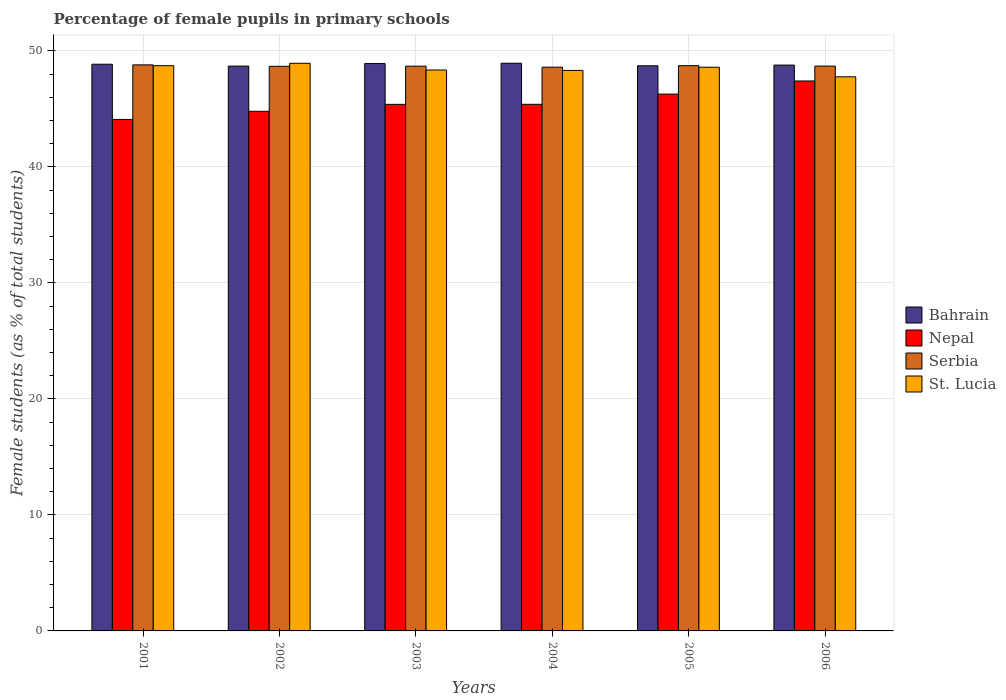How many different coloured bars are there?
Keep it short and to the point. 4. Are the number of bars per tick equal to the number of legend labels?
Offer a terse response. Yes. How many bars are there on the 2nd tick from the right?
Keep it short and to the point. 4. What is the percentage of female pupils in primary schools in St. Lucia in 2006?
Your answer should be compact. 47.77. Across all years, what is the maximum percentage of female pupils in primary schools in St. Lucia?
Provide a short and direct response. 48.93. Across all years, what is the minimum percentage of female pupils in primary schools in Nepal?
Make the answer very short. 44.09. What is the total percentage of female pupils in primary schools in Bahrain in the graph?
Provide a succinct answer. 292.89. What is the difference between the percentage of female pupils in primary schools in Serbia in 2005 and that in 2006?
Ensure brevity in your answer.  0.04. What is the difference between the percentage of female pupils in primary schools in Nepal in 2003 and the percentage of female pupils in primary schools in Bahrain in 2001?
Give a very brief answer. -3.46. What is the average percentage of female pupils in primary schools in Serbia per year?
Give a very brief answer. 48.7. In the year 2006, what is the difference between the percentage of female pupils in primary schools in Nepal and percentage of female pupils in primary schools in St. Lucia?
Provide a short and direct response. -0.36. In how many years, is the percentage of female pupils in primary schools in Nepal greater than 6 %?
Ensure brevity in your answer.  6. What is the ratio of the percentage of female pupils in primary schools in St. Lucia in 2001 to that in 2006?
Your answer should be very brief. 1.02. Is the percentage of female pupils in primary schools in Serbia in 2002 less than that in 2004?
Keep it short and to the point. No. Is the difference between the percentage of female pupils in primary schools in Nepal in 2005 and 2006 greater than the difference between the percentage of female pupils in primary schools in St. Lucia in 2005 and 2006?
Provide a succinct answer. No. What is the difference between the highest and the second highest percentage of female pupils in primary schools in Bahrain?
Provide a succinct answer. 0.03. What is the difference between the highest and the lowest percentage of female pupils in primary schools in St. Lucia?
Ensure brevity in your answer.  1.17. In how many years, is the percentage of female pupils in primary schools in Nepal greater than the average percentage of female pupils in primary schools in Nepal taken over all years?
Offer a very short reply. 2. What does the 4th bar from the left in 2001 represents?
Make the answer very short. St. Lucia. What does the 1st bar from the right in 2004 represents?
Give a very brief answer. St. Lucia. Is it the case that in every year, the sum of the percentage of female pupils in primary schools in Serbia and percentage of female pupils in primary schools in St. Lucia is greater than the percentage of female pupils in primary schools in Nepal?
Your response must be concise. Yes. How many bars are there?
Make the answer very short. 24. How many years are there in the graph?
Provide a short and direct response. 6. What is the difference between two consecutive major ticks on the Y-axis?
Offer a terse response. 10. Are the values on the major ticks of Y-axis written in scientific E-notation?
Make the answer very short. No. Does the graph contain any zero values?
Ensure brevity in your answer.  No. Does the graph contain grids?
Provide a short and direct response. Yes. Where does the legend appear in the graph?
Your answer should be compact. Center right. How are the legend labels stacked?
Keep it short and to the point. Vertical. What is the title of the graph?
Provide a succinct answer. Percentage of female pupils in primary schools. What is the label or title of the X-axis?
Provide a succinct answer. Years. What is the label or title of the Y-axis?
Offer a very short reply. Female students (as % of total students). What is the Female students (as % of total students) in Bahrain in 2001?
Provide a short and direct response. 48.85. What is the Female students (as % of total students) of Nepal in 2001?
Give a very brief answer. 44.09. What is the Female students (as % of total students) of Serbia in 2001?
Offer a very short reply. 48.8. What is the Female students (as % of total students) of St. Lucia in 2001?
Your answer should be compact. 48.73. What is the Female students (as % of total students) of Bahrain in 2002?
Offer a very short reply. 48.69. What is the Female students (as % of total students) of Nepal in 2002?
Make the answer very short. 44.8. What is the Female students (as % of total students) in Serbia in 2002?
Your answer should be very brief. 48.67. What is the Female students (as % of total students) of St. Lucia in 2002?
Offer a very short reply. 48.93. What is the Female students (as % of total students) of Bahrain in 2003?
Keep it short and to the point. 48.91. What is the Female students (as % of total students) of Nepal in 2003?
Provide a short and direct response. 45.39. What is the Female students (as % of total students) of Serbia in 2003?
Your response must be concise. 48.69. What is the Female students (as % of total students) of St. Lucia in 2003?
Your response must be concise. 48.35. What is the Female students (as % of total students) of Bahrain in 2004?
Provide a short and direct response. 48.94. What is the Female students (as % of total students) of Nepal in 2004?
Ensure brevity in your answer.  45.4. What is the Female students (as % of total students) in Serbia in 2004?
Provide a succinct answer. 48.6. What is the Female students (as % of total students) of St. Lucia in 2004?
Offer a terse response. 48.32. What is the Female students (as % of total students) in Bahrain in 2005?
Your answer should be very brief. 48.72. What is the Female students (as % of total students) in Nepal in 2005?
Give a very brief answer. 46.28. What is the Female students (as % of total students) of Serbia in 2005?
Ensure brevity in your answer.  48.73. What is the Female students (as % of total students) in St. Lucia in 2005?
Provide a short and direct response. 48.59. What is the Female students (as % of total students) in Bahrain in 2006?
Provide a short and direct response. 48.78. What is the Female students (as % of total students) of Nepal in 2006?
Provide a short and direct response. 47.41. What is the Female students (as % of total students) in Serbia in 2006?
Offer a very short reply. 48.69. What is the Female students (as % of total students) of St. Lucia in 2006?
Make the answer very short. 47.77. Across all years, what is the maximum Female students (as % of total students) in Bahrain?
Your answer should be very brief. 48.94. Across all years, what is the maximum Female students (as % of total students) in Nepal?
Keep it short and to the point. 47.41. Across all years, what is the maximum Female students (as % of total students) in Serbia?
Offer a terse response. 48.8. Across all years, what is the maximum Female students (as % of total students) in St. Lucia?
Ensure brevity in your answer.  48.93. Across all years, what is the minimum Female students (as % of total students) in Bahrain?
Offer a terse response. 48.69. Across all years, what is the minimum Female students (as % of total students) in Nepal?
Keep it short and to the point. 44.09. Across all years, what is the minimum Female students (as % of total students) of Serbia?
Offer a very short reply. 48.6. Across all years, what is the minimum Female students (as % of total students) of St. Lucia?
Offer a terse response. 47.77. What is the total Female students (as % of total students) of Bahrain in the graph?
Make the answer very short. 292.88. What is the total Female students (as % of total students) in Nepal in the graph?
Provide a succinct answer. 273.37. What is the total Female students (as % of total students) of Serbia in the graph?
Ensure brevity in your answer.  292.17. What is the total Female students (as % of total students) of St. Lucia in the graph?
Provide a short and direct response. 290.69. What is the difference between the Female students (as % of total students) in Bahrain in 2001 and that in 2002?
Provide a short and direct response. 0.16. What is the difference between the Female students (as % of total students) of Nepal in 2001 and that in 2002?
Ensure brevity in your answer.  -0.7. What is the difference between the Female students (as % of total students) in Serbia in 2001 and that in 2002?
Offer a very short reply. 0.12. What is the difference between the Female students (as % of total students) in St. Lucia in 2001 and that in 2002?
Ensure brevity in your answer.  -0.21. What is the difference between the Female students (as % of total students) in Bahrain in 2001 and that in 2003?
Ensure brevity in your answer.  -0.06. What is the difference between the Female students (as % of total students) in Nepal in 2001 and that in 2003?
Provide a succinct answer. -1.3. What is the difference between the Female students (as % of total students) in Serbia in 2001 and that in 2003?
Provide a short and direct response. 0.11. What is the difference between the Female students (as % of total students) in St. Lucia in 2001 and that in 2003?
Ensure brevity in your answer.  0.37. What is the difference between the Female students (as % of total students) of Bahrain in 2001 and that in 2004?
Your response must be concise. -0.08. What is the difference between the Female students (as % of total students) of Nepal in 2001 and that in 2004?
Keep it short and to the point. -1.3. What is the difference between the Female students (as % of total students) in Serbia in 2001 and that in 2004?
Provide a succinct answer. 0.2. What is the difference between the Female students (as % of total students) in St. Lucia in 2001 and that in 2004?
Ensure brevity in your answer.  0.41. What is the difference between the Female students (as % of total students) in Bahrain in 2001 and that in 2005?
Provide a short and direct response. 0.13. What is the difference between the Female students (as % of total students) of Nepal in 2001 and that in 2005?
Offer a terse response. -2.18. What is the difference between the Female students (as % of total students) of Serbia in 2001 and that in 2005?
Offer a terse response. 0.07. What is the difference between the Female students (as % of total students) of St. Lucia in 2001 and that in 2005?
Offer a terse response. 0.13. What is the difference between the Female students (as % of total students) of Bahrain in 2001 and that in 2006?
Provide a short and direct response. 0.07. What is the difference between the Female students (as % of total students) in Nepal in 2001 and that in 2006?
Your answer should be very brief. -3.31. What is the difference between the Female students (as % of total students) in Serbia in 2001 and that in 2006?
Ensure brevity in your answer.  0.1. What is the difference between the Female students (as % of total students) of St. Lucia in 2001 and that in 2006?
Give a very brief answer. 0.96. What is the difference between the Female students (as % of total students) in Bahrain in 2002 and that in 2003?
Ensure brevity in your answer.  -0.22. What is the difference between the Female students (as % of total students) of Nepal in 2002 and that in 2003?
Give a very brief answer. -0.6. What is the difference between the Female students (as % of total students) of Serbia in 2002 and that in 2003?
Your answer should be compact. -0.01. What is the difference between the Female students (as % of total students) in St. Lucia in 2002 and that in 2003?
Keep it short and to the point. 0.58. What is the difference between the Female students (as % of total students) in Bahrain in 2002 and that in 2004?
Give a very brief answer. -0.24. What is the difference between the Female students (as % of total students) in Nepal in 2002 and that in 2004?
Provide a succinct answer. -0.6. What is the difference between the Female students (as % of total students) of Serbia in 2002 and that in 2004?
Give a very brief answer. 0.07. What is the difference between the Female students (as % of total students) in St. Lucia in 2002 and that in 2004?
Your answer should be very brief. 0.62. What is the difference between the Female students (as % of total students) of Bahrain in 2002 and that in 2005?
Your answer should be very brief. -0.03. What is the difference between the Female students (as % of total students) in Nepal in 2002 and that in 2005?
Give a very brief answer. -1.48. What is the difference between the Female students (as % of total students) in Serbia in 2002 and that in 2005?
Your answer should be very brief. -0.06. What is the difference between the Female students (as % of total students) of St. Lucia in 2002 and that in 2005?
Offer a terse response. 0.34. What is the difference between the Female students (as % of total students) in Bahrain in 2002 and that in 2006?
Offer a terse response. -0.09. What is the difference between the Female students (as % of total students) in Nepal in 2002 and that in 2006?
Your answer should be very brief. -2.61. What is the difference between the Female students (as % of total students) in Serbia in 2002 and that in 2006?
Give a very brief answer. -0.02. What is the difference between the Female students (as % of total students) in St. Lucia in 2002 and that in 2006?
Give a very brief answer. 1.17. What is the difference between the Female students (as % of total students) of Bahrain in 2003 and that in 2004?
Your answer should be very brief. -0.03. What is the difference between the Female students (as % of total students) in Nepal in 2003 and that in 2004?
Make the answer very short. -0. What is the difference between the Female students (as % of total students) in Serbia in 2003 and that in 2004?
Make the answer very short. 0.09. What is the difference between the Female students (as % of total students) in St. Lucia in 2003 and that in 2004?
Give a very brief answer. 0.04. What is the difference between the Female students (as % of total students) of Bahrain in 2003 and that in 2005?
Provide a short and direct response. 0.19. What is the difference between the Female students (as % of total students) in Nepal in 2003 and that in 2005?
Make the answer very short. -0.88. What is the difference between the Female students (as % of total students) of Serbia in 2003 and that in 2005?
Your answer should be compact. -0.04. What is the difference between the Female students (as % of total students) in St. Lucia in 2003 and that in 2005?
Keep it short and to the point. -0.24. What is the difference between the Female students (as % of total students) of Bahrain in 2003 and that in 2006?
Your answer should be very brief. 0.13. What is the difference between the Female students (as % of total students) in Nepal in 2003 and that in 2006?
Make the answer very short. -2.01. What is the difference between the Female students (as % of total students) in Serbia in 2003 and that in 2006?
Provide a succinct answer. -0.01. What is the difference between the Female students (as % of total students) of St. Lucia in 2003 and that in 2006?
Offer a terse response. 0.59. What is the difference between the Female students (as % of total students) in Bahrain in 2004 and that in 2005?
Give a very brief answer. 0.22. What is the difference between the Female students (as % of total students) in Nepal in 2004 and that in 2005?
Your answer should be compact. -0.88. What is the difference between the Female students (as % of total students) in Serbia in 2004 and that in 2005?
Offer a very short reply. -0.13. What is the difference between the Female students (as % of total students) in St. Lucia in 2004 and that in 2005?
Provide a short and direct response. -0.28. What is the difference between the Female students (as % of total students) in Bahrain in 2004 and that in 2006?
Your answer should be very brief. 0.16. What is the difference between the Female students (as % of total students) in Nepal in 2004 and that in 2006?
Give a very brief answer. -2.01. What is the difference between the Female students (as % of total students) of Serbia in 2004 and that in 2006?
Provide a short and direct response. -0.09. What is the difference between the Female students (as % of total students) of St. Lucia in 2004 and that in 2006?
Provide a succinct answer. 0.55. What is the difference between the Female students (as % of total students) of Bahrain in 2005 and that in 2006?
Your answer should be very brief. -0.06. What is the difference between the Female students (as % of total students) of Nepal in 2005 and that in 2006?
Your answer should be very brief. -1.13. What is the difference between the Female students (as % of total students) in Serbia in 2005 and that in 2006?
Ensure brevity in your answer.  0.04. What is the difference between the Female students (as % of total students) in St. Lucia in 2005 and that in 2006?
Your answer should be very brief. 0.83. What is the difference between the Female students (as % of total students) in Bahrain in 2001 and the Female students (as % of total students) in Nepal in 2002?
Provide a short and direct response. 4.06. What is the difference between the Female students (as % of total students) of Bahrain in 2001 and the Female students (as % of total students) of Serbia in 2002?
Offer a very short reply. 0.18. What is the difference between the Female students (as % of total students) of Bahrain in 2001 and the Female students (as % of total students) of St. Lucia in 2002?
Your answer should be very brief. -0.08. What is the difference between the Female students (as % of total students) in Nepal in 2001 and the Female students (as % of total students) in Serbia in 2002?
Keep it short and to the point. -4.58. What is the difference between the Female students (as % of total students) in Nepal in 2001 and the Female students (as % of total students) in St. Lucia in 2002?
Offer a terse response. -4.84. What is the difference between the Female students (as % of total students) in Serbia in 2001 and the Female students (as % of total students) in St. Lucia in 2002?
Your answer should be very brief. -0.14. What is the difference between the Female students (as % of total students) of Bahrain in 2001 and the Female students (as % of total students) of Nepal in 2003?
Offer a very short reply. 3.46. What is the difference between the Female students (as % of total students) of Bahrain in 2001 and the Female students (as % of total students) of Serbia in 2003?
Offer a terse response. 0.17. What is the difference between the Female students (as % of total students) in Bahrain in 2001 and the Female students (as % of total students) in St. Lucia in 2003?
Your response must be concise. 0.5. What is the difference between the Female students (as % of total students) of Nepal in 2001 and the Female students (as % of total students) of Serbia in 2003?
Your answer should be compact. -4.59. What is the difference between the Female students (as % of total students) of Nepal in 2001 and the Female students (as % of total students) of St. Lucia in 2003?
Offer a very short reply. -4.26. What is the difference between the Female students (as % of total students) of Serbia in 2001 and the Female students (as % of total students) of St. Lucia in 2003?
Your answer should be very brief. 0.44. What is the difference between the Female students (as % of total students) in Bahrain in 2001 and the Female students (as % of total students) in Nepal in 2004?
Give a very brief answer. 3.45. What is the difference between the Female students (as % of total students) of Bahrain in 2001 and the Female students (as % of total students) of Serbia in 2004?
Make the answer very short. 0.25. What is the difference between the Female students (as % of total students) in Bahrain in 2001 and the Female students (as % of total students) in St. Lucia in 2004?
Ensure brevity in your answer.  0.53. What is the difference between the Female students (as % of total students) in Nepal in 2001 and the Female students (as % of total students) in Serbia in 2004?
Provide a succinct answer. -4.5. What is the difference between the Female students (as % of total students) of Nepal in 2001 and the Female students (as % of total students) of St. Lucia in 2004?
Your answer should be very brief. -4.23. What is the difference between the Female students (as % of total students) of Serbia in 2001 and the Female students (as % of total students) of St. Lucia in 2004?
Make the answer very short. 0.48. What is the difference between the Female students (as % of total students) of Bahrain in 2001 and the Female students (as % of total students) of Nepal in 2005?
Your response must be concise. 2.57. What is the difference between the Female students (as % of total students) in Bahrain in 2001 and the Female students (as % of total students) in Serbia in 2005?
Your response must be concise. 0.12. What is the difference between the Female students (as % of total students) in Bahrain in 2001 and the Female students (as % of total students) in St. Lucia in 2005?
Give a very brief answer. 0.26. What is the difference between the Female students (as % of total students) in Nepal in 2001 and the Female students (as % of total students) in Serbia in 2005?
Ensure brevity in your answer.  -4.64. What is the difference between the Female students (as % of total students) of Nepal in 2001 and the Female students (as % of total students) of St. Lucia in 2005?
Provide a succinct answer. -4.5. What is the difference between the Female students (as % of total students) of Serbia in 2001 and the Female students (as % of total students) of St. Lucia in 2005?
Your response must be concise. 0.2. What is the difference between the Female students (as % of total students) in Bahrain in 2001 and the Female students (as % of total students) in Nepal in 2006?
Keep it short and to the point. 1.44. What is the difference between the Female students (as % of total students) in Bahrain in 2001 and the Female students (as % of total students) in Serbia in 2006?
Offer a terse response. 0.16. What is the difference between the Female students (as % of total students) of Bahrain in 2001 and the Female students (as % of total students) of St. Lucia in 2006?
Offer a very short reply. 1.09. What is the difference between the Female students (as % of total students) of Nepal in 2001 and the Female students (as % of total students) of Serbia in 2006?
Offer a terse response. -4.6. What is the difference between the Female students (as % of total students) of Nepal in 2001 and the Female students (as % of total students) of St. Lucia in 2006?
Provide a succinct answer. -3.67. What is the difference between the Female students (as % of total students) of Serbia in 2001 and the Female students (as % of total students) of St. Lucia in 2006?
Your response must be concise. 1.03. What is the difference between the Female students (as % of total students) in Bahrain in 2002 and the Female students (as % of total students) in Nepal in 2003?
Provide a short and direct response. 3.3. What is the difference between the Female students (as % of total students) in Bahrain in 2002 and the Female students (as % of total students) in Serbia in 2003?
Offer a very short reply. 0.01. What is the difference between the Female students (as % of total students) of Bahrain in 2002 and the Female students (as % of total students) of St. Lucia in 2003?
Ensure brevity in your answer.  0.34. What is the difference between the Female students (as % of total students) in Nepal in 2002 and the Female students (as % of total students) in Serbia in 2003?
Make the answer very short. -3.89. What is the difference between the Female students (as % of total students) of Nepal in 2002 and the Female students (as % of total students) of St. Lucia in 2003?
Your response must be concise. -3.56. What is the difference between the Female students (as % of total students) in Serbia in 2002 and the Female students (as % of total students) in St. Lucia in 2003?
Offer a terse response. 0.32. What is the difference between the Female students (as % of total students) of Bahrain in 2002 and the Female students (as % of total students) of Nepal in 2004?
Offer a terse response. 3.29. What is the difference between the Female students (as % of total students) of Bahrain in 2002 and the Female students (as % of total students) of Serbia in 2004?
Give a very brief answer. 0.09. What is the difference between the Female students (as % of total students) of Bahrain in 2002 and the Female students (as % of total students) of St. Lucia in 2004?
Your answer should be very brief. 0.37. What is the difference between the Female students (as % of total students) of Nepal in 2002 and the Female students (as % of total students) of Serbia in 2004?
Provide a short and direct response. -3.8. What is the difference between the Female students (as % of total students) of Nepal in 2002 and the Female students (as % of total students) of St. Lucia in 2004?
Offer a very short reply. -3.52. What is the difference between the Female students (as % of total students) of Serbia in 2002 and the Female students (as % of total students) of St. Lucia in 2004?
Your response must be concise. 0.35. What is the difference between the Female students (as % of total students) in Bahrain in 2002 and the Female students (as % of total students) in Nepal in 2005?
Ensure brevity in your answer.  2.41. What is the difference between the Female students (as % of total students) of Bahrain in 2002 and the Female students (as % of total students) of Serbia in 2005?
Keep it short and to the point. -0.04. What is the difference between the Female students (as % of total students) of Bahrain in 2002 and the Female students (as % of total students) of St. Lucia in 2005?
Provide a short and direct response. 0.1. What is the difference between the Female students (as % of total students) of Nepal in 2002 and the Female students (as % of total students) of Serbia in 2005?
Ensure brevity in your answer.  -3.93. What is the difference between the Female students (as % of total students) of Nepal in 2002 and the Female students (as % of total students) of St. Lucia in 2005?
Provide a short and direct response. -3.8. What is the difference between the Female students (as % of total students) of Serbia in 2002 and the Female students (as % of total students) of St. Lucia in 2005?
Provide a succinct answer. 0.08. What is the difference between the Female students (as % of total students) in Bahrain in 2002 and the Female students (as % of total students) in Nepal in 2006?
Offer a terse response. 1.28. What is the difference between the Female students (as % of total students) in Bahrain in 2002 and the Female students (as % of total students) in Serbia in 2006?
Provide a succinct answer. -0. What is the difference between the Female students (as % of total students) of Bahrain in 2002 and the Female students (as % of total students) of St. Lucia in 2006?
Make the answer very short. 0.92. What is the difference between the Female students (as % of total students) in Nepal in 2002 and the Female students (as % of total students) in Serbia in 2006?
Provide a short and direct response. -3.9. What is the difference between the Female students (as % of total students) in Nepal in 2002 and the Female students (as % of total students) in St. Lucia in 2006?
Offer a very short reply. -2.97. What is the difference between the Female students (as % of total students) of Serbia in 2002 and the Female students (as % of total students) of St. Lucia in 2006?
Offer a terse response. 0.91. What is the difference between the Female students (as % of total students) of Bahrain in 2003 and the Female students (as % of total students) of Nepal in 2004?
Offer a terse response. 3.51. What is the difference between the Female students (as % of total students) in Bahrain in 2003 and the Female students (as % of total students) in Serbia in 2004?
Offer a very short reply. 0.31. What is the difference between the Female students (as % of total students) of Bahrain in 2003 and the Female students (as % of total students) of St. Lucia in 2004?
Provide a short and direct response. 0.59. What is the difference between the Female students (as % of total students) in Nepal in 2003 and the Female students (as % of total students) in Serbia in 2004?
Your response must be concise. -3.2. What is the difference between the Female students (as % of total students) of Nepal in 2003 and the Female students (as % of total students) of St. Lucia in 2004?
Keep it short and to the point. -2.93. What is the difference between the Female students (as % of total students) of Serbia in 2003 and the Female students (as % of total students) of St. Lucia in 2004?
Provide a short and direct response. 0.37. What is the difference between the Female students (as % of total students) of Bahrain in 2003 and the Female students (as % of total students) of Nepal in 2005?
Provide a succinct answer. 2.63. What is the difference between the Female students (as % of total students) of Bahrain in 2003 and the Female students (as % of total students) of Serbia in 2005?
Ensure brevity in your answer.  0.18. What is the difference between the Female students (as % of total students) in Bahrain in 2003 and the Female students (as % of total students) in St. Lucia in 2005?
Your response must be concise. 0.32. What is the difference between the Female students (as % of total students) of Nepal in 2003 and the Female students (as % of total students) of Serbia in 2005?
Give a very brief answer. -3.34. What is the difference between the Female students (as % of total students) in Nepal in 2003 and the Female students (as % of total students) in St. Lucia in 2005?
Keep it short and to the point. -3.2. What is the difference between the Female students (as % of total students) of Serbia in 2003 and the Female students (as % of total students) of St. Lucia in 2005?
Provide a succinct answer. 0.09. What is the difference between the Female students (as % of total students) of Bahrain in 2003 and the Female students (as % of total students) of Nepal in 2006?
Provide a short and direct response. 1.5. What is the difference between the Female students (as % of total students) in Bahrain in 2003 and the Female students (as % of total students) in Serbia in 2006?
Make the answer very short. 0.22. What is the difference between the Female students (as % of total students) of Bahrain in 2003 and the Female students (as % of total students) of St. Lucia in 2006?
Your answer should be compact. 1.14. What is the difference between the Female students (as % of total students) in Nepal in 2003 and the Female students (as % of total students) in Serbia in 2006?
Offer a terse response. -3.3. What is the difference between the Female students (as % of total students) of Nepal in 2003 and the Female students (as % of total students) of St. Lucia in 2006?
Your answer should be very brief. -2.37. What is the difference between the Female students (as % of total students) in Serbia in 2003 and the Female students (as % of total students) in St. Lucia in 2006?
Provide a short and direct response. 0.92. What is the difference between the Female students (as % of total students) of Bahrain in 2004 and the Female students (as % of total students) of Nepal in 2005?
Keep it short and to the point. 2.66. What is the difference between the Female students (as % of total students) of Bahrain in 2004 and the Female students (as % of total students) of Serbia in 2005?
Offer a very short reply. 0.21. What is the difference between the Female students (as % of total students) in Bahrain in 2004 and the Female students (as % of total students) in St. Lucia in 2005?
Offer a very short reply. 0.34. What is the difference between the Female students (as % of total students) of Nepal in 2004 and the Female students (as % of total students) of Serbia in 2005?
Your answer should be compact. -3.33. What is the difference between the Female students (as % of total students) in Nepal in 2004 and the Female students (as % of total students) in St. Lucia in 2005?
Provide a short and direct response. -3.2. What is the difference between the Female students (as % of total students) of Serbia in 2004 and the Female students (as % of total students) of St. Lucia in 2005?
Your answer should be very brief. 0. What is the difference between the Female students (as % of total students) of Bahrain in 2004 and the Female students (as % of total students) of Nepal in 2006?
Offer a terse response. 1.53. What is the difference between the Female students (as % of total students) of Bahrain in 2004 and the Female students (as % of total students) of Serbia in 2006?
Ensure brevity in your answer.  0.24. What is the difference between the Female students (as % of total students) of Bahrain in 2004 and the Female students (as % of total students) of St. Lucia in 2006?
Provide a succinct answer. 1.17. What is the difference between the Female students (as % of total students) in Nepal in 2004 and the Female students (as % of total students) in Serbia in 2006?
Offer a very short reply. -3.29. What is the difference between the Female students (as % of total students) in Nepal in 2004 and the Female students (as % of total students) in St. Lucia in 2006?
Make the answer very short. -2.37. What is the difference between the Female students (as % of total students) in Serbia in 2004 and the Female students (as % of total students) in St. Lucia in 2006?
Provide a succinct answer. 0.83. What is the difference between the Female students (as % of total students) of Bahrain in 2005 and the Female students (as % of total students) of Nepal in 2006?
Provide a succinct answer. 1.31. What is the difference between the Female students (as % of total students) in Bahrain in 2005 and the Female students (as % of total students) in Serbia in 2006?
Your response must be concise. 0.03. What is the difference between the Female students (as % of total students) in Bahrain in 2005 and the Female students (as % of total students) in St. Lucia in 2006?
Keep it short and to the point. 0.95. What is the difference between the Female students (as % of total students) in Nepal in 2005 and the Female students (as % of total students) in Serbia in 2006?
Provide a short and direct response. -2.41. What is the difference between the Female students (as % of total students) of Nepal in 2005 and the Female students (as % of total students) of St. Lucia in 2006?
Provide a succinct answer. -1.49. What is the difference between the Female students (as % of total students) in Serbia in 2005 and the Female students (as % of total students) in St. Lucia in 2006?
Ensure brevity in your answer.  0.96. What is the average Female students (as % of total students) of Bahrain per year?
Provide a short and direct response. 48.81. What is the average Female students (as % of total students) of Nepal per year?
Provide a succinct answer. 45.56. What is the average Female students (as % of total students) in Serbia per year?
Provide a short and direct response. 48.7. What is the average Female students (as % of total students) in St. Lucia per year?
Your answer should be compact. 48.45. In the year 2001, what is the difference between the Female students (as % of total students) in Bahrain and Female students (as % of total students) in Nepal?
Offer a very short reply. 4.76. In the year 2001, what is the difference between the Female students (as % of total students) of Bahrain and Female students (as % of total students) of Serbia?
Ensure brevity in your answer.  0.06. In the year 2001, what is the difference between the Female students (as % of total students) in Bahrain and Female students (as % of total students) in St. Lucia?
Your answer should be compact. 0.13. In the year 2001, what is the difference between the Female students (as % of total students) of Nepal and Female students (as % of total students) of Serbia?
Your answer should be compact. -4.7. In the year 2001, what is the difference between the Female students (as % of total students) in Nepal and Female students (as % of total students) in St. Lucia?
Provide a short and direct response. -4.63. In the year 2001, what is the difference between the Female students (as % of total students) in Serbia and Female students (as % of total students) in St. Lucia?
Provide a succinct answer. 0.07. In the year 2002, what is the difference between the Female students (as % of total students) of Bahrain and Female students (as % of total students) of Nepal?
Offer a terse response. 3.9. In the year 2002, what is the difference between the Female students (as % of total students) of Bahrain and Female students (as % of total students) of Serbia?
Keep it short and to the point. 0.02. In the year 2002, what is the difference between the Female students (as % of total students) in Bahrain and Female students (as % of total students) in St. Lucia?
Make the answer very short. -0.24. In the year 2002, what is the difference between the Female students (as % of total students) of Nepal and Female students (as % of total students) of Serbia?
Keep it short and to the point. -3.88. In the year 2002, what is the difference between the Female students (as % of total students) of Nepal and Female students (as % of total students) of St. Lucia?
Your response must be concise. -4.14. In the year 2002, what is the difference between the Female students (as % of total students) of Serbia and Female students (as % of total students) of St. Lucia?
Your answer should be very brief. -0.26. In the year 2003, what is the difference between the Female students (as % of total students) in Bahrain and Female students (as % of total students) in Nepal?
Your answer should be compact. 3.52. In the year 2003, what is the difference between the Female students (as % of total students) in Bahrain and Female students (as % of total students) in Serbia?
Keep it short and to the point. 0.23. In the year 2003, what is the difference between the Female students (as % of total students) of Bahrain and Female students (as % of total students) of St. Lucia?
Your answer should be compact. 0.56. In the year 2003, what is the difference between the Female students (as % of total students) of Nepal and Female students (as % of total students) of Serbia?
Provide a succinct answer. -3.29. In the year 2003, what is the difference between the Female students (as % of total students) of Nepal and Female students (as % of total students) of St. Lucia?
Your response must be concise. -2.96. In the year 2003, what is the difference between the Female students (as % of total students) of Serbia and Female students (as % of total students) of St. Lucia?
Give a very brief answer. 0.33. In the year 2004, what is the difference between the Female students (as % of total students) in Bahrain and Female students (as % of total students) in Nepal?
Keep it short and to the point. 3.54. In the year 2004, what is the difference between the Female students (as % of total students) in Bahrain and Female students (as % of total students) in Serbia?
Offer a terse response. 0.34. In the year 2004, what is the difference between the Female students (as % of total students) of Bahrain and Female students (as % of total students) of St. Lucia?
Your answer should be very brief. 0.62. In the year 2004, what is the difference between the Female students (as % of total students) in Nepal and Female students (as % of total students) in Serbia?
Offer a terse response. -3.2. In the year 2004, what is the difference between the Female students (as % of total students) in Nepal and Female students (as % of total students) in St. Lucia?
Offer a terse response. -2.92. In the year 2004, what is the difference between the Female students (as % of total students) in Serbia and Female students (as % of total students) in St. Lucia?
Keep it short and to the point. 0.28. In the year 2005, what is the difference between the Female students (as % of total students) in Bahrain and Female students (as % of total students) in Nepal?
Give a very brief answer. 2.44. In the year 2005, what is the difference between the Female students (as % of total students) of Bahrain and Female students (as % of total students) of Serbia?
Offer a very short reply. -0.01. In the year 2005, what is the difference between the Female students (as % of total students) of Bahrain and Female students (as % of total students) of St. Lucia?
Your answer should be very brief. 0.12. In the year 2005, what is the difference between the Female students (as % of total students) in Nepal and Female students (as % of total students) in Serbia?
Your answer should be very brief. -2.45. In the year 2005, what is the difference between the Female students (as % of total students) of Nepal and Female students (as % of total students) of St. Lucia?
Your answer should be very brief. -2.32. In the year 2005, what is the difference between the Female students (as % of total students) of Serbia and Female students (as % of total students) of St. Lucia?
Offer a very short reply. 0.14. In the year 2006, what is the difference between the Female students (as % of total students) in Bahrain and Female students (as % of total students) in Nepal?
Offer a very short reply. 1.37. In the year 2006, what is the difference between the Female students (as % of total students) in Bahrain and Female students (as % of total students) in Serbia?
Your answer should be compact. 0.09. In the year 2006, what is the difference between the Female students (as % of total students) of Bahrain and Female students (as % of total students) of St. Lucia?
Keep it short and to the point. 1.01. In the year 2006, what is the difference between the Female students (as % of total students) of Nepal and Female students (as % of total students) of Serbia?
Ensure brevity in your answer.  -1.28. In the year 2006, what is the difference between the Female students (as % of total students) of Nepal and Female students (as % of total students) of St. Lucia?
Ensure brevity in your answer.  -0.36. In the year 2006, what is the difference between the Female students (as % of total students) in Serbia and Female students (as % of total students) in St. Lucia?
Offer a terse response. 0.93. What is the ratio of the Female students (as % of total students) of Bahrain in 2001 to that in 2002?
Ensure brevity in your answer.  1. What is the ratio of the Female students (as % of total students) of Nepal in 2001 to that in 2002?
Offer a very short reply. 0.98. What is the ratio of the Female students (as % of total students) of Serbia in 2001 to that in 2002?
Offer a terse response. 1. What is the ratio of the Female students (as % of total students) of St. Lucia in 2001 to that in 2002?
Offer a terse response. 1. What is the ratio of the Female students (as % of total students) of Nepal in 2001 to that in 2003?
Provide a succinct answer. 0.97. What is the ratio of the Female students (as % of total students) in Serbia in 2001 to that in 2003?
Offer a terse response. 1. What is the ratio of the Female students (as % of total students) in St. Lucia in 2001 to that in 2003?
Make the answer very short. 1.01. What is the ratio of the Female students (as % of total students) of Nepal in 2001 to that in 2004?
Your answer should be very brief. 0.97. What is the ratio of the Female students (as % of total students) of St. Lucia in 2001 to that in 2004?
Offer a terse response. 1.01. What is the ratio of the Female students (as % of total students) of Bahrain in 2001 to that in 2005?
Your answer should be very brief. 1. What is the ratio of the Female students (as % of total students) in Nepal in 2001 to that in 2005?
Your response must be concise. 0.95. What is the ratio of the Female students (as % of total students) of Serbia in 2001 to that in 2005?
Your answer should be compact. 1. What is the ratio of the Female students (as % of total students) of Bahrain in 2001 to that in 2006?
Your answer should be very brief. 1. What is the ratio of the Female students (as % of total students) in Nepal in 2001 to that in 2006?
Give a very brief answer. 0.93. What is the ratio of the Female students (as % of total students) in Serbia in 2001 to that in 2006?
Offer a terse response. 1. What is the ratio of the Female students (as % of total students) of St. Lucia in 2001 to that in 2006?
Offer a very short reply. 1.02. What is the ratio of the Female students (as % of total students) of Serbia in 2002 to that in 2003?
Offer a terse response. 1. What is the ratio of the Female students (as % of total students) in Nepal in 2002 to that in 2004?
Give a very brief answer. 0.99. What is the ratio of the Female students (as % of total students) of St. Lucia in 2002 to that in 2004?
Ensure brevity in your answer.  1.01. What is the ratio of the Female students (as % of total students) in Bahrain in 2002 to that in 2005?
Your answer should be compact. 1. What is the ratio of the Female students (as % of total students) of Serbia in 2002 to that in 2005?
Make the answer very short. 1. What is the ratio of the Female students (as % of total students) in St. Lucia in 2002 to that in 2005?
Provide a short and direct response. 1.01. What is the ratio of the Female students (as % of total students) of Bahrain in 2002 to that in 2006?
Offer a very short reply. 1. What is the ratio of the Female students (as % of total students) in Nepal in 2002 to that in 2006?
Make the answer very short. 0.94. What is the ratio of the Female students (as % of total students) in Serbia in 2002 to that in 2006?
Ensure brevity in your answer.  1. What is the ratio of the Female students (as % of total students) in St. Lucia in 2002 to that in 2006?
Your answer should be compact. 1.02. What is the ratio of the Female students (as % of total students) in Bahrain in 2003 to that in 2004?
Make the answer very short. 1. What is the ratio of the Female students (as % of total students) of Bahrain in 2003 to that in 2005?
Provide a short and direct response. 1. What is the ratio of the Female students (as % of total students) of Nepal in 2003 to that in 2005?
Your answer should be very brief. 0.98. What is the ratio of the Female students (as % of total students) of St. Lucia in 2003 to that in 2005?
Keep it short and to the point. 1. What is the ratio of the Female students (as % of total students) in Bahrain in 2003 to that in 2006?
Keep it short and to the point. 1. What is the ratio of the Female students (as % of total students) in Nepal in 2003 to that in 2006?
Provide a succinct answer. 0.96. What is the ratio of the Female students (as % of total students) of St. Lucia in 2003 to that in 2006?
Provide a short and direct response. 1.01. What is the ratio of the Female students (as % of total students) in Nepal in 2004 to that in 2005?
Your response must be concise. 0.98. What is the ratio of the Female students (as % of total students) of St. Lucia in 2004 to that in 2005?
Provide a succinct answer. 0.99. What is the ratio of the Female students (as % of total students) in Bahrain in 2004 to that in 2006?
Give a very brief answer. 1. What is the ratio of the Female students (as % of total students) of Nepal in 2004 to that in 2006?
Your answer should be very brief. 0.96. What is the ratio of the Female students (as % of total students) of St. Lucia in 2004 to that in 2006?
Keep it short and to the point. 1.01. What is the ratio of the Female students (as % of total students) in Nepal in 2005 to that in 2006?
Provide a short and direct response. 0.98. What is the ratio of the Female students (as % of total students) of Serbia in 2005 to that in 2006?
Provide a succinct answer. 1. What is the ratio of the Female students (as % of total students) in St. Lucia in 2005 to that in 2006?
Offer a terse response. 1.02. What is the difference between the highest and the second highest Female students (as % of total students) of Bahrain?
Your answer should be compact. 0.03. What is the difference between the highest and the second highest Female students (as % of total students) in Nepal?
Offer a very short reply. 1.13. What is the difference between the highest and the second highest Female students (as % of total students) in Serbia?
Your answer should be compact. 0.07. What is the difference between the highest and the second highest Female students (as % of total students) of St. Lucia?
Ensure brevity in your answer.  0.21. What is the difference between the highest and the lowest Female students (as % of total students) in Bahrain?
Provide a short and direct response. 0.24. What is the difference between the highest and the lowest Female students (as % of total students) of Nepal?
Ensure brevity in your answer.  3.31. What is the difference between the highest and the lowest Female students (as % of total students) in Serbia?
Give a very brief answer. 0.2. What is the difference between the highest and the lowest Female students (as % of total students) of St. Lucia?
Your answer should be compact. 1.17. 